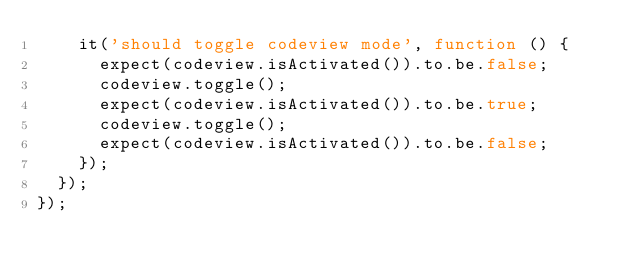<code> <loc_0><loc_0><loc_500><loc_500><_JavaScript_>    it('should toggle codeview mode', function () {
      expect(codeview.isActivated()).to.be.false;
      codeview.toggle();
      expect(codeview.isActivated()).to.be.true;
      codeview.toggle();
      expect(codeview.isActivated()).to.be.false;
    });
  });
});
</code> 